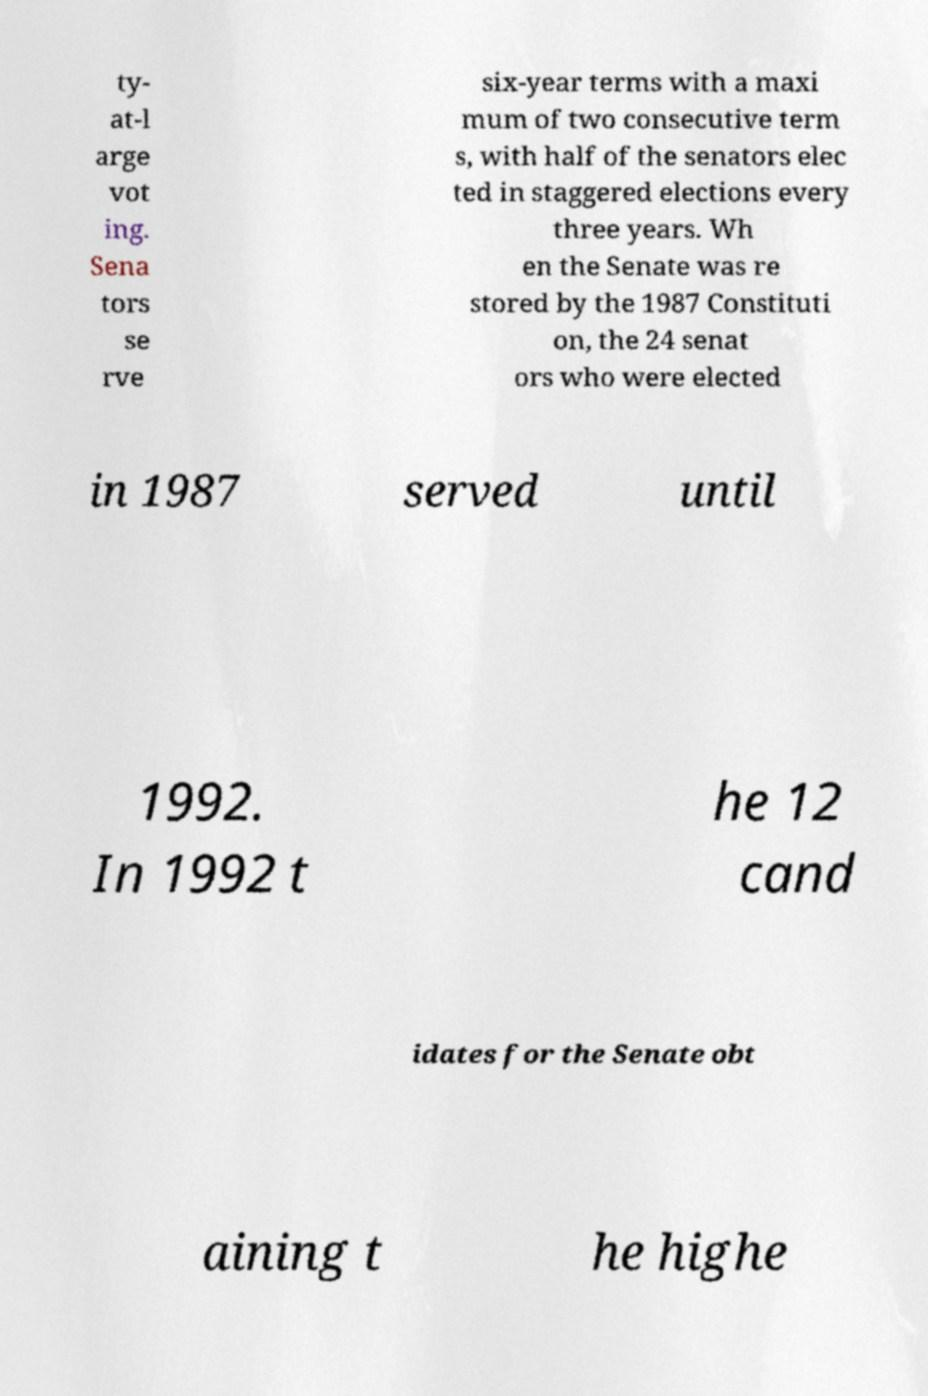There's text embedded in this image that I need extracted. Can you transcribe it verbatim? ty- at-l arge vot ing. Sena tors se rve six-year terms with a maxi mum of two consecutive term s, with half of the senators elec ted in staggered elections every three years. Wh en the Senate was re stored by the 1987 Constituti on, the 24 senat ors who were elected in 1987 served until 1992. In 1992 t he 12 cand idates for the Senate obt aining t he highe 